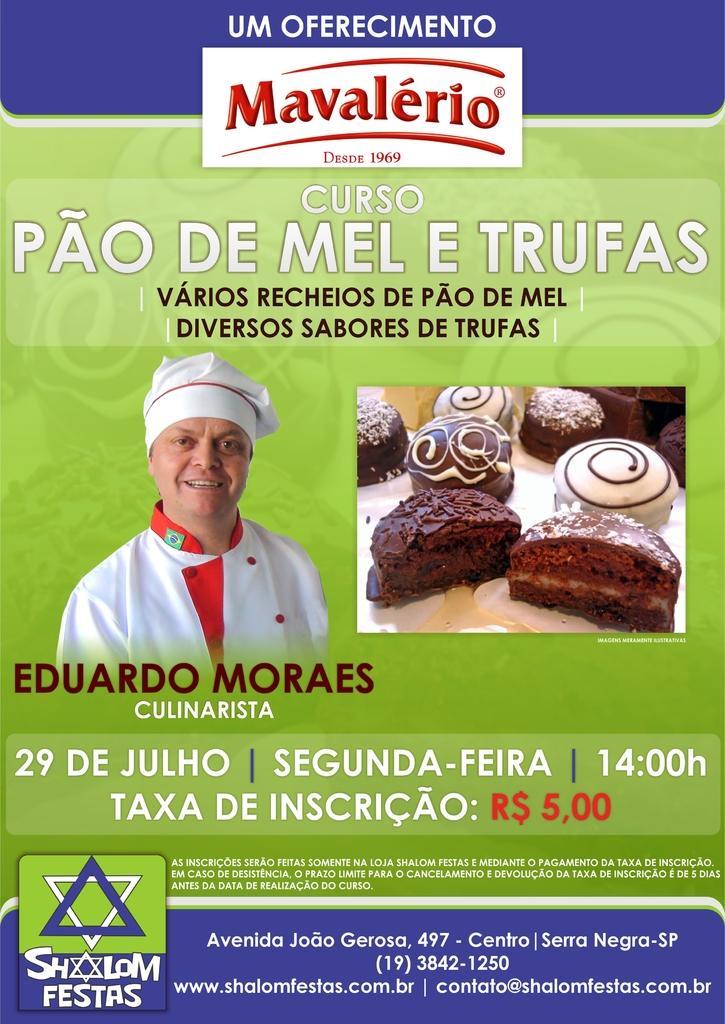Describe this image in one or two sentences. In this image I can see a person wearing white and red color dress. I can see few cakes and something is written on it. Background is in green,blue and white color. 